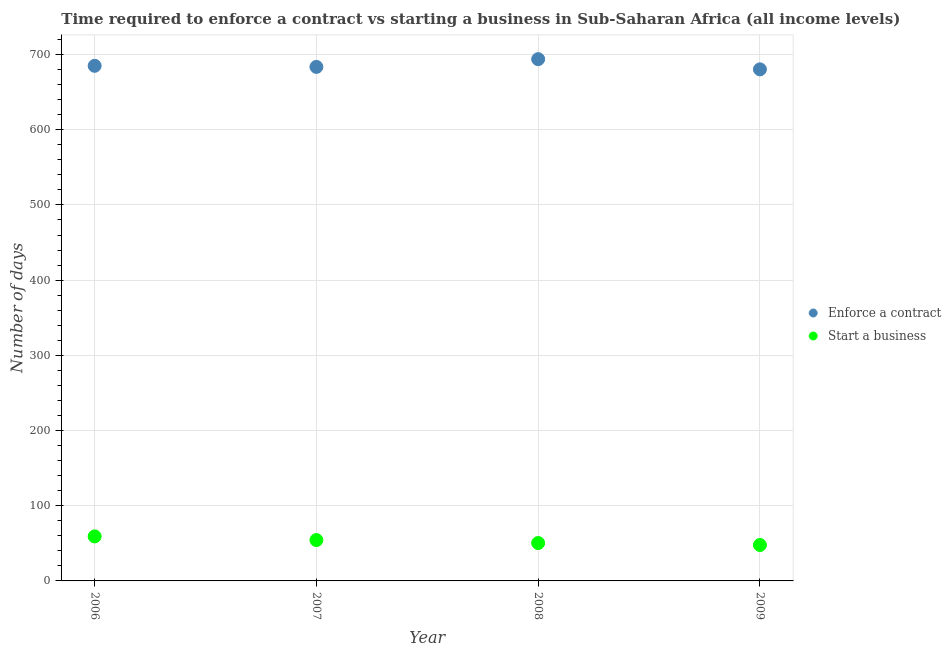What is the number of days to enforece a contract in 2009?
Give a very brief answer. 680.36. Across all years, what is the maximum number of days to start a business?
Provide a short and direct response. 59.2. Across all years, what is the minimum number of days to enforece a contract?
Your response must be concise. 680.36. In which year was the number of days to enforece a contract maximum?
Your response must be concise. 2008. What is the total number of days to enforece a contract in the graph?
Your answer should be very brief. 2742.89. What is the difference between the number of days to start a business in 2006 and that in 2009?
Give a very brief answer. 11.42. What is the difference between the number of days to start a business in 2007 and the number of days to enforece a contract in 2008?
Offer a terse response. -639.56. What is the average number of days to start a business per year?
Keep it short and to the point. 52.92. In the year 2009, what is the difference between the number of days to enforece a contract and number of days to start a business?
Your response must be concise. 632.58. In how many years, is the number of days to enforece a contract greater than 520 days?
Make the answer very short. 4. What is the ratio of the number of days to start a business in 2006 to that in 2007?
Provide a succinct answer. 1.09. Is the number of days to start a business in 2007 less than that in 2009?
Make the answer very short. No. Is the difference between the number of days to enforece a contract in 2008 and 2009 greater than the difference between the number of days to start a business in 2008 and 2009?
Your response must be concise. Yes. What is the difference between the highest and the second highest number of days to enforece a contract?
Offer a terse response. 8.84. What is the difference between the highest and the lowest number of days to enforece a contract?
Your answer should be compact. 13.53. Is the sum of the number of days to enforece a contract in 2007 and 2009 greater than the maximum number of days to start a business across all years?
Offer a very short reply. Yes. Is the number of days to enforece a contract strictly greater than the number of days to start a business over the years?
Ensure brevity in your answer.  Yes. How many dotlines are there?
Provide a succinct answer. 2. Are the values on the major ticks of Y-axis written in scientific E-notation?
Offer a terse response. No. Does the graph contain any zero values?
Offer a terse response. No. Does the graph contain grids?
Your answer should be compact. Yes. Where does the legend appear in the graph?
Offer a very short reply. Center right. How many legend labels are there?
Your answer should be very brief. 2. How are the legend labels stacked?
Keep it short and to the point. Vertical. What is the title of the graph?
Provide a succinct answer. Time required to enforce a contract vs starting a business in Sub-Saharan Africa (all income levels). What is the label or title of the Y-axis?
Make the answer very short. Number of days. What is the Number of days of Enforce a contract in 2006?
Provide a short and direct response. 685.04. What is the Number of days in Start a business in 2006?
Provide a short and direct response. 59.2. What is the Number of days of Enforce a contract in 2007?
Offer a very short reply. 683.6. What is the Number of days in Start a business in 2007?
Offer a very short reply. 54.33. What is the Number of days in Enforce a contract in 2008?
Offer a terse response. 693.89. What is the Number of days in Start a business in 2008?
Provide a succinct answer. 50.38. What is the Number of days in Enforce a contract in 2009?
Give a very brief answer. 680.36. What is the Number of days in Start a business in 2009?
Keep it short and to the point. 47.78. Across all years, what is the maximum Number of days in Enforce a contract?
Your response must be concise. 693.89. Across all years, what is the maximum Number of days of Start a business?
Your answer should be compact. 59.2. Across all years, what is the minimum Number of days of Enforce a contract?
Ensure brevity in your answer.  680.36. Across all years, what is the minimum Number of days in Start a business?
Provide a short and direct response. 47.78. What is the total Number of days of Enforce a contract in the graph?
Provide a short and direct response. 2742.89. What is the total Number of days of Start a business in the graph?
Your response must be concise. 211.69. What is the difference between the Number of days of Enforce a contract in 2006 and that in 2007?
Provide a succinct answer. 1.44. What is the difference between the Number of days of Start a business in 2006 and that in 2007?
Your answer should be compact. 4.87. What is the difference between the Number of days in Enforce a contract in 2006 and that in 2008?
Your response must be concise. -8.84. What is the difference between the Number of days in Start a business in 2006 and that in 2008?
Your answer should be compact. 8.82. What is the difference between the Number of days in Enforce a contract in 2006 and that in 2009?
Your answer should be compact. 4.69. What is the difference between the Number of days of Start a business in 2006 and that in 2009?
Provide a succinct answer. 11.42. What is the difference between the Number of days of Enforce a contract in 2007 and that in 2008?
Provide a succinct answer. -10.29. What is the difference between the Number of days in Start a business in 2007 and that in 2008?
Make the answer very short. 3.96. What is the difference between the Number of days in Enforce a contract in 2007 and that in 2009?
Offer a very short reply. 3.24. What is the difference between the Number of days of Start a business in 2007 and that in 2009?
Your answer should be compact. 6.56. What is the difference between the Number of days in Enforce a contract in 2008 and that in 2009?
Your response must be concise. 13.53. What is the difference between the Number of days in Start a business in 2008 and that in 2009?
Offer a terse response. 2.6. What is the difference between the Number of days in Enforce a contract in 2006 and the Number of days in Start a business in 2007?
Give a very brief answer. 630.71. What is the difference between the Number of days in Enforce a contract in 2006 and the Number of days in Start a business in 2008?
Your answer should be compact. 634.67. What is the difference between the Number of days in Enforce a contract in 2006 and the Number of days in Start a business in 2009?
Your answer should be very brief. 637.27. What is the difference between the Number of days of Enforce a contract in 2007 and the Number of days of Start a business in 2008?
Make the answer very short. 633.22. What is the difference between the Number of days in Enforce a contract in 2007 and the Number of days in Start a business in 2009?
Ensure brevity in your answer.  635.82. What is the difference between the Number of days in Enforce a contract in 2008 and the Number of days in Start a business in 2009?
Your answer should be very brief. 646.11. What is the average Number of days in Enforce a contract per year?
Your answer should be compact. 685.72. What is the average Number of days in Start a business per year?
Keep it short and to the point. 52.92. In the year 2006, what is the difference between the Number of days of Enforce a contract and Number of days of Start a business?
Your answer should be compact. 625.84. In the year 2007, what is the difference between the Number of days of Enforce a contract and Number of days of Start a business?
Offer a terse response. 629.27. In the year 2008, what is the difference between the Number of days of Enforce a contract and Number of days of Start a business?
Your response must be concise. 643.51. In the year 2009, what is the difference between the Number of days in Enforce a contract and Number of days in Start a business?
Your answer should be very brief. 632.58. What is the ratio of the Number of days in Start a business in 2006 to that in 2007?
Your response must be concise. 1.09. What is the ratio of the Number of days in Enforce a contract in 2006 to that in 2008?
Keep it short and to the point. 0.99. What is the ratio of the Number of days in Start a business in 2006 to that in 2008?
Your answer should be very brief. 1.18. What is the ratio of the Number of days in Enforce a contract in 2006 to that in 2009?
Give a very brief answer. 1.01. What is the ratio of the Number of days of Start a business in 2006 to that in 2009?
Give a very brief answer. 1.24. What is the ratio of the Number of days in Enforce a contract in 2007 to that in 2008?
Your answer should be very brief. 0.99. What is the ratio of the Number of days of Start a business in 2007 to that in 2008?
Offer a very short reply. 1.08. What is the ratio of the Number of days of Enforce a contract in 2007 to that in 2009?
Offer a very short reply. 1. What is the ratio of the Number of days in Start a business in 2007 to that in 2009?
Offer a terse response. 1.14. What is the ratio of the Number of days in Enforce a contract in 2008 to that in 2009?
Offer a terse response. 1.02. What is the ratio of the Number of days of Start a business in 2008 to that in 2009?
Your answer should be compact. 1.05. What is the difference between the highest and the second highest Number of days in Enforce a contract?
Your answer should be very brief. 8.84. What is the difference between the highest and the second highest Number of days of Start a business?
Your answer should be compact. 4.87. What is the difference between the highest and the lowest Number of days in Enforce a contract?
Your response must be concise. 13.53. What is the difference between the highest and the lowest Number of days in Start a business?
Offer a very short reply. 11.42. 